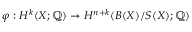Convert formula to latex. <formula><loc_0><loc_0><loc_500><loc_500>\varphi \colon H ^ { k } ( X ; \mathbb { Q } ) \to H ^ { n + k } ( B ( X ) / S ( X ) ; \mathbb { Q } )</formula> 